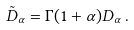<formula> <loc_0><loc_0><loc_500><loc_500>\tilde { D } _ { \alpha } = \Gamma ( 1 + \alpha ) D _ { \alpha } \, .</formula> 